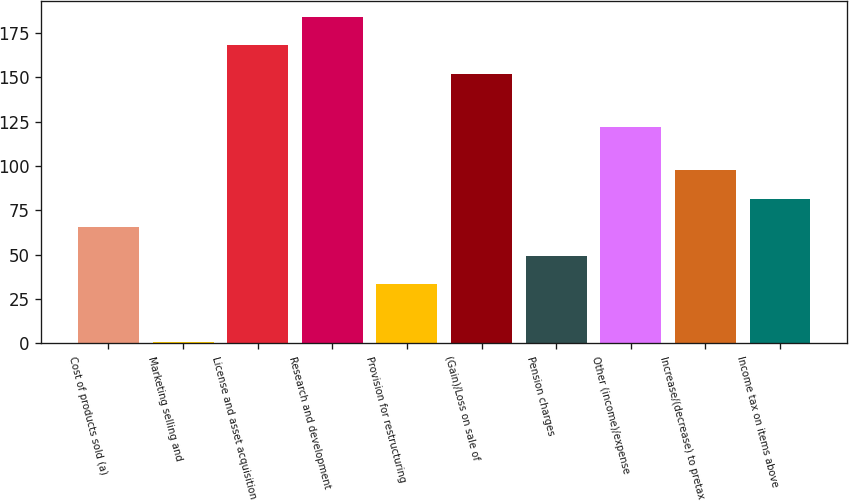<chart> <loc_0><loc_0><loc_500><loc_500><bar_chart><fcel>Cost of products sold (a)<fcel>Marketing selling and<fcel>License and asset acquisition<fcel>Research and development<fcel>Provision for restructuring<fcel>(Gain)/Loss on sale of<fcel>Pension charges<fcel>Other (income)/expense<fcel>Increase/(decrease) to pretax<fcel>Income tax on items above<nl><fcel>65.4<fcel>1<fcel>168.1<fcel>184.2<fcel>33.2<fcel>152<fcel>49.3<fcel>122<fcel>97.6<fcel>81.5<nl></chart> 